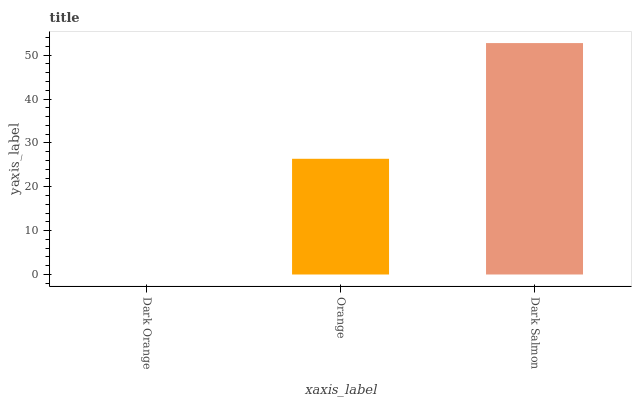Is Dark Orange the minimum?
Answer yes or no. Yes. Is Dark Salmon the maximum?
Answer yes or no. Yes. Is Orange the minimum?
Answer yes or no. No. Is Orange the maximum?
Answer yes or no. No. Is Orange greater than Dark Orange?
Answer yes or no. Yes. Is Dark Orange less than Orange?
Answer yes or no. Yes. Is Dark Orange greater than Orange?
Answer yes or no. No. Is Orange less than Dark Orange?
Answer yes or no. No. Is Orange the high median?
Answer yes or no. Yes. Is Orange the low median?
Answer yes or no. Yes. Is Dark Salmon the high median?
Answer yes or no. No. Is Dark Orange the low median?
Answer yes or no. No. 